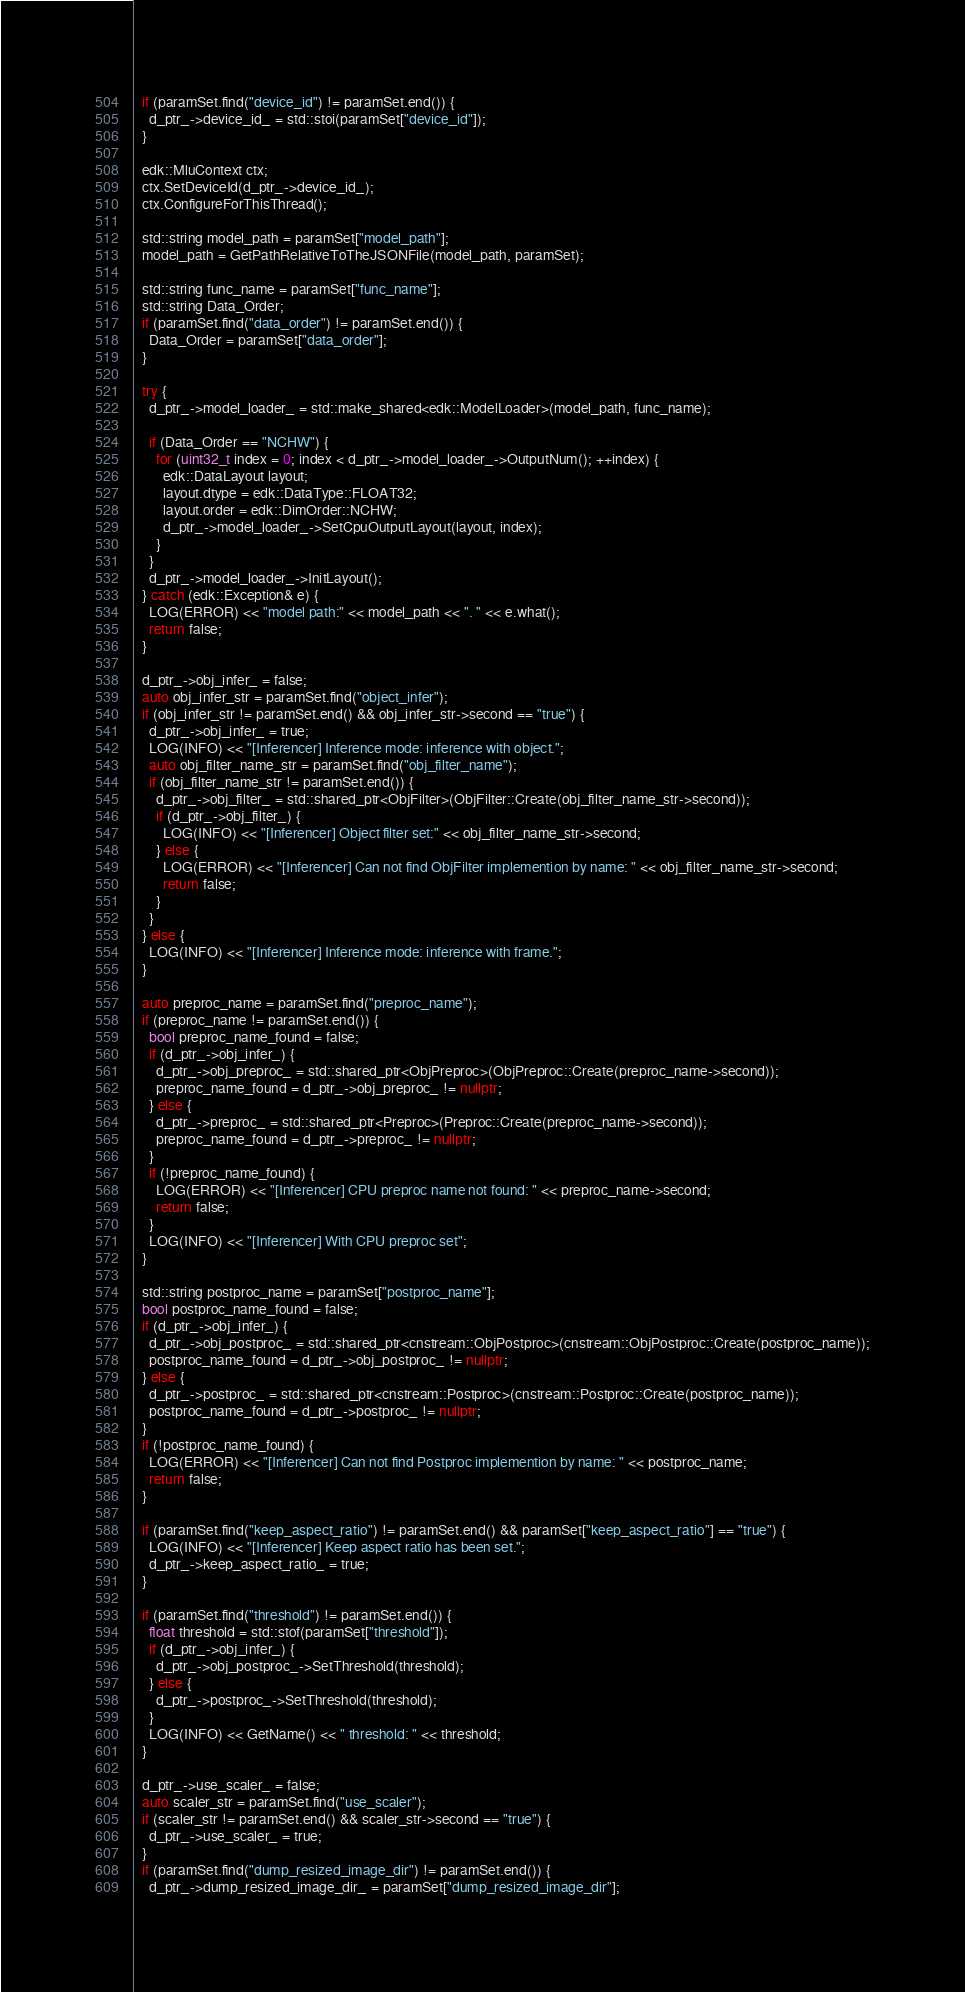Convert code to text. <code><loc_0><loc_0><loc_500><loc_500><_C++_>  if (paramSet.find("device_id") != paramSet.end()) {
    d_ptr_->device_id_ = std::stoi(paramSet["device_id"]);
  }

  edk::MluContext ctx;
  ctx.SetDeviceId(d_ptr_->device_id_);
  ctx.ConfigureForThisThread();

  std::string model_path = paramSet["model_path"];
  model_path = GetPathRelativeToTheJSONFile(model_path, paramSet);

  std::string func_name = paramSet["func_name"];
  std::string Data_Order;
  if (paramSet.find("data_order") != paramSet.end()) {
    Data_Order = paramSet["data_order"];
  }

  try {
    d_ptr_->model_loader_ = std::make_shared<edk::ModelLoader>(model_path, func_name);

    if (Data_Order == "NCHW") {
      for (uint32_t index = 0; index < d_ptr_->model_loader_->OutputNum(); ++index) {
        edk::DataLayout layout;
        layout.dtype = edk::DataType::FLOAT32;
        layout.order = edk::DimOrder::NCHW;
        d_ptr_->model_loader_->SetCpuOutputLayout(layout, index);
      }
    }
    d_ptr_->model_loader_->InitLayout();
  } catch (edk::Exception& e) {
    LOG(ERROR) << "model path:" << model_path << ". " << e.what();
    return false;
  }

  d_ptr_->obj_infer_ = false;
  auto obj_infer_str = paramSet.find("object_infer");
  if (obj_infer_str != paramSet.end() && obj_infer_str->second == "true") {
    d_ptr_->obj_infer_ = true;
    LOG(INFO) << "[Inferencer] Inference mode: inference with object.";
    auto obj_filter_name_str = paramSet.find("obj_filter_name");
    if (obj_filter_name_str != paramSet.end()) {
      d_ptr_->obj_filter_ = std::shared_ptr<ObjFilter>(ObjFilter::Create(obj_filter_name_str->second));
      if (d_ptr_->obj_filter_) {
        LOG(INFO) << "[Inferencer] Object filter set:" << obj_filter_name_str->second;
      } else {
        LOG(ERROR) << "[Inferencer] Can not find ObjFilter implemention by name: " << obj_filter_name_str->second;
        return false;
      }
    }
  } else {
    LOG(INFO) << "[Inferencer] Inference mode: inference with frame.";
  }

  auto preproc_name = paramSet.find("preproc_name");
  if (preproc_name != paramSet.end()) {
    bool preproc_name_found = false;
    if (d_ptr_->obj_infer_) {
      d_ptr_->obj_preproc_ = std::shared_ptr<ObjPreproc>(ObjPreproc::Create(preproc_name->second));
      preproc_name_found = d_ptr_->obj_preproc_ != nullptr;
    } else {
      d_ptr_->preproc_ = std::shared_ptr<Preproc>(Preproc::Create(preproc_name->second));
      preproc_name_found = d_ptr_->preproc_ != nullptr;
    }
    if (!preproc_name_found) {
      LOG(ERROR) << "[Inferencer] CPU preproc name not found: " << preproc_name->second;
      return false;
    }
    LOG(INFO) << "[Inferencer] With CPU preproc set";
  }

  std::string postproc_name = paramSet["postproc_name"];
  bool postproc_name_found = false;
  if (d_ptr_->obj_infer_) {
    d_ptr_->obj_postproc_ = std::shared_ptr<cnstream::ObjPostproc>(cnstream::ObjPostproc::Create(postproc_name));
    postproc_name_found = d_ptr_->obj_postproc_ != nullptr;
  } else {
    d_ptr_->postproc_ = std::shared_ptr<cnstream::Postproc>(cnstream::Postproc::Create(postproc_name));
    postproc_name_found = d_ptr_->postproc_ != nullptr;
  }
  if (!postproc_name_found) {
    LOG(ERROR) << "[Inferencer] Can not find Postproc implemention by name: " << postproc_name;
    return false;
  }

  if (paramSet.find("keep_aspect_ratio") != paramSet.end() && paramSet["keep_aspect_ratio"] == "true") {
    LOG(INFO) << "[Inferencer] Keep aspect ratio has been set.";
    d_ptr_->keep_aspect_ratio_ = true;
  }

  if (paramSet.find("threshold") != paramSet.end()) {
    float threshold = std::stof(paramSet["threshold"]);
    if (d_ptr_->obj_infer_) {
      d_ptr_->obj_postproc_->SetThreshold(threshold);
    } else {
      d_ptr_->postproc_->SetThreshold(threshold);
    }
    LOG(INFO) << GetName() << " threshold: " << threshold;
  }

  d_ptr_->use_scaler_ = false;
  auto scaler_str = paramSet.find("use_scaler");
  if (scaler_str != paramSet.end() && scaler_str->second == "true") {
    d_ptr_->use_scaler_ = true;
  }
  if (paramSet.find("dump_resized_image_dir") != paramSet.end()) {
    d_ptr_->dump_resized_image_dir_ = paramSet["dump_resized_image_dir"];</code> 